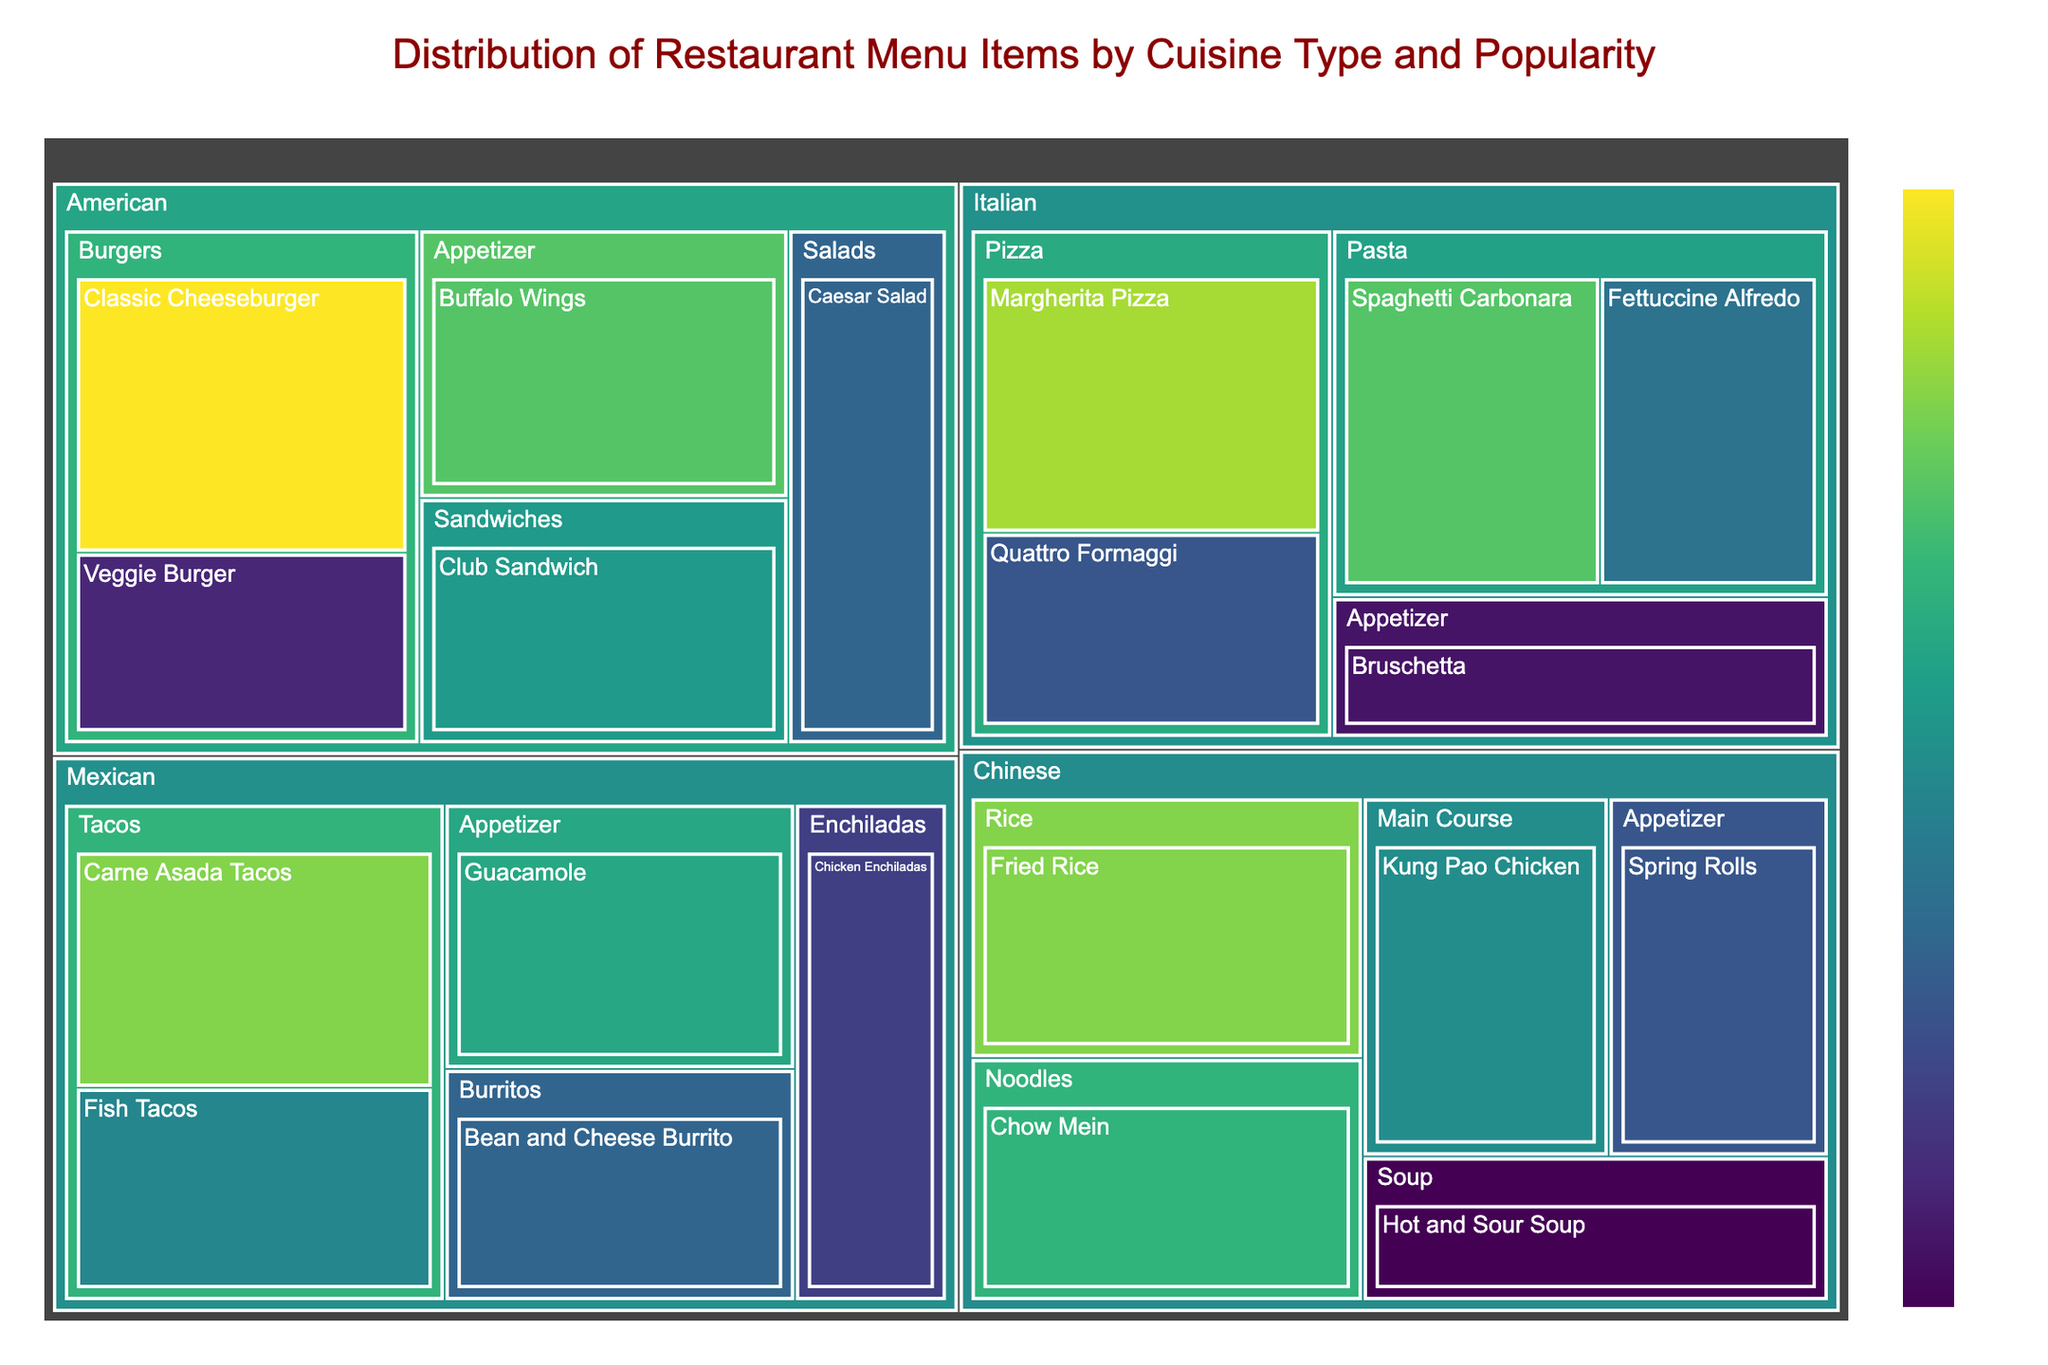What is the most popular menu item in the plot? The item with the highest popularity score is the most popular. By checking the popularity values, the Classic Cheeseburger is the highest with a score of 95.
Answer: Classic Cheeseburger How many cuisine types are displayed in the treemap? The number of distinct parent categories in the treemap represents the different cuisine types. The cuisine types are Italian, Mexican, American, and Chinese.
Answer: 4 Which item in the Italian cuisine is the least popular? Within the Italian cuisine category, the item with the lowest popularity score is Bruschetta with a score of 60.
Answer: Bruschetta How does the popularity of Carne Asada Tacos compare to Fish Tacos? The popularity of Carne Asada Tacos is 88, while that of Fish Tacos is 75. Therefore, Carne Asada Tacos are more popular.
Answer: Carne Asada Tacos are more popular What is the combined popularity score of all appetizers? Summing up the popularity scores of all appetizer items across the cuisines: 60 (Bruschetta) + 80 (Guacamole) + 85 (Buffalo Wings) + 68 (Spring Rolls) = 293.
Answer: 293 Which cuisine has the highest average popularity across its items? First, calculate the average popularity for each cuisine:
- Italian: (85 + 72 + 90 + 68 + 60) / 5 = 75
- Mexican: (88 + 75 + 70 + 65 + 80) / 5 = 75.6
- American: (95 + 62 + 78 + 85 + 70) / 5 = 78
- Chinese: (82 + 88 + 76 + 68 + 58) / 5 = 74.4
The American cuisine has the highest average popularity of 78.
Answer: American What is the least popular item overall? The item with the lowest popularity score is Hot and Sour Soup with a score of 58.
Answer: Hot and Sour Soup Which category within the Chinese cuisine has the highest cumulative popularity? Sum the popularity scores of items within each category:
- Noodles: 82
- Rice: 88
- Main Course: 76
- Appetizer: 68
- Soup: 58
Fried Rice, belonging to the Rice category, has the highest cumulative popularity of 88.
Answer: Rice Between Burgers and Tacos, which category is more popular? Calculate the cumulative popularity of items in both categories:
- Burgers: 95 (Classic Cheeseburger) + 62 (Veggie Burger) = 157
- Tacos: 88 (Carne Asada Tacos) + 75 (Fish Tacos) = 163
Tacos are more popular with a cumulative popularity of 163.
Answer: Tacos 